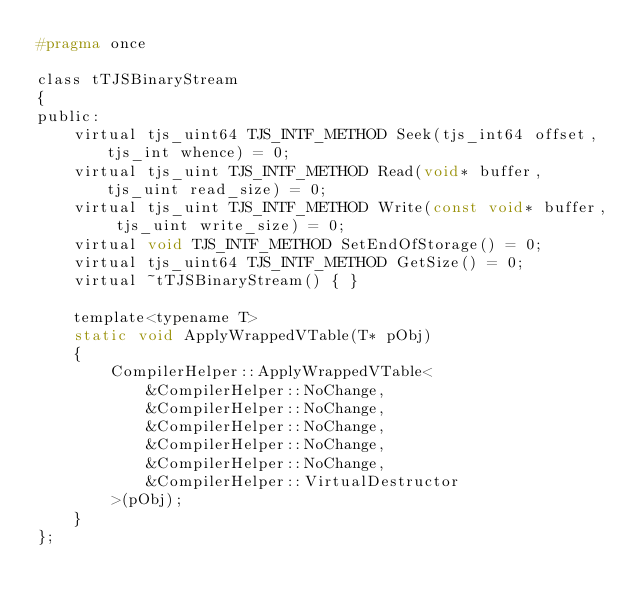Convert code to text. <code><loc_0><loc_0><loc_500><loc_500><_C_>#pragma once

class tTJSBinaryStream
{
public:
	virtual tjs_uint64 TJS_INTF_METHOD Seek(tjs_int64 offset, tjs_int whence) = 0;
	virtual tjs_uint TJS_INTF_METHOD Read(void* buffer, tjs_uint read_size) = 0;
	virtual tjs_uint TJS_INTF_METHOD Write(const void* buffer, tjs_uint write_size) = 0;
	virtual void TJS_INTF_METHOD SetEndOfStorage() = 0;
	virtual tjs_uint64 TJS_INTF_METHOD GetSize() = 0;
	virtual ~tTJSBinaryStream() { }

	template<typename T>
	static void ApplyWrappedVTable(T* pObj)
	{
		CompilerHelper::ApplyWrappedVTable<
			&CompilerHelper::NoChange,
	        &CompilerHelper::NoChange,
	        &CompilerHelper::NoChange,
	        &CompilerHelper::NoChange,
	        &CompilerHelper::NoChange,
	        &CompilerHelper::VirtualDestructor
        >(pObj);
	}
};
</code> 